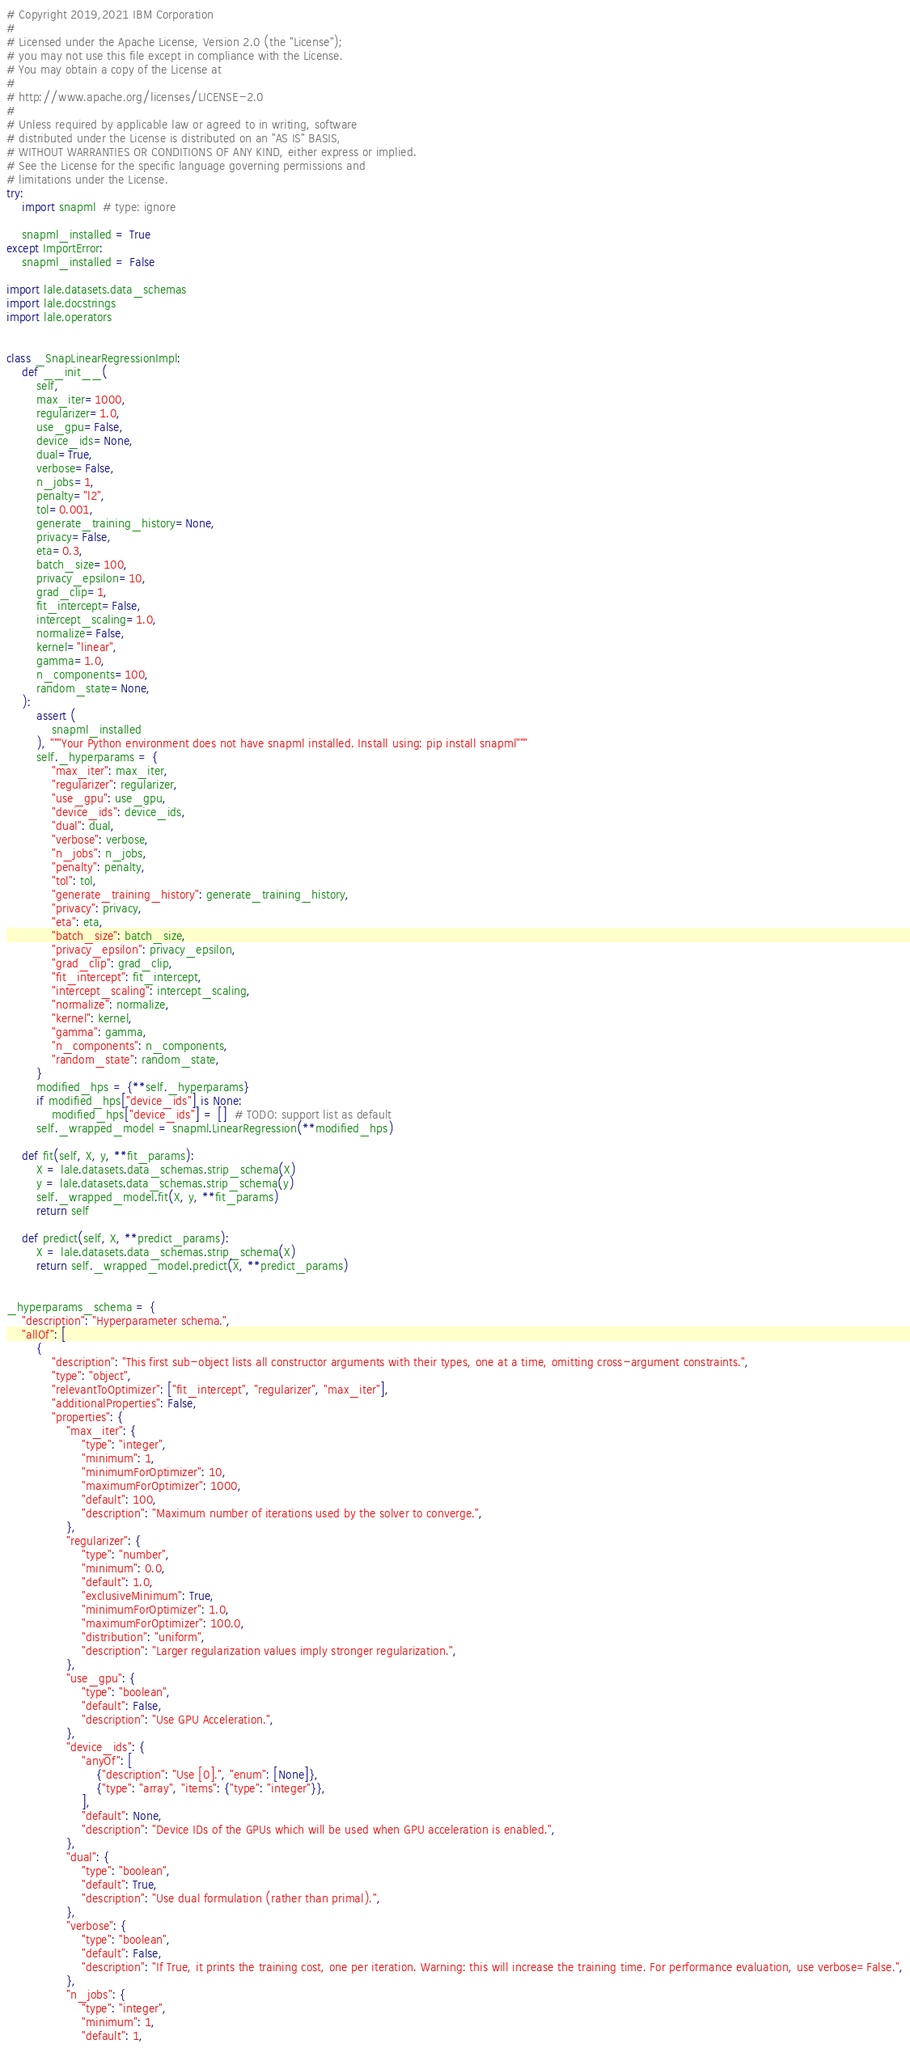<code> <loc_0><loc_0><loc_500><loc_500><_Python_># Copyright 2019,2021 IBM Corporation
#
# Licensed under the Apache License, Version 2.0 (the "License");
# you may not use this file except in compliance with the License.
# You may obtain a copy of the License at
#
# http://www.apache.org/licenses/LICENSE-2.0
#
# Unless required by applicable law or agreed to in writing, software
# distributed under the License is distributed on an "AS IS" BASIS,
# WITHOUT WARRANTIES OR CONDITIONS OF ANY KIND, either express or implied.
# See the License for the specific language governing permissions and
# limitations under the License.
try:
    import snapml  # type: ignore

    snapml_installed = True
except ImportError:
    snapml_installed = False

import lale.datasets.data_schemas
import lale.docstrings
import lale.operators


class _SnapLinearRegressionImpl:
    def __init__(
        self,
        max_iter=1000,
        regularizer=1.0,
        use_gpu=False,
        device_ids=None,
        dual=True,
        verbose=False,
        n_jobs=1,
        penalty="l2",
        tol=0.001,
        generate_training_history=None,
        privacy=False,
        eta=0.3,
        batch_size=100,
        privacy_epsilon=10,
        grad_clip=1,
        fit_intercept=False,
        intercept_scaling=1.0,
        normalize=False,
        kernel="linear",
        gamma=1.0,
        n_components=100,
        random_state=None,
    ):
        assert (
            snapml_installed
        ), """Your Python environment does not have snapml installed. Install using: pip install snapml"""
        self._hyperparams = {
            "max_iter": max_iter,
            "regularizer": regularizer,
            "use_gpu": use_gpu,
            "device_ids": device_ids,
            "dual": dual,
            "verbose": verbose,
            "n_jobs": n_jobs,
            "penalty": penalty,
            "tol": tol,
            "generate_training_history": generate_training_history,
            "privacy": privacy,
            "eta": eta,
            "batch_size": batch_size,
            "privacy_epsilon": privacy_epsilon,
            "grad_clip": grad_clip,
            "fit_intercept": fit_intercept,
            "intercept_scaling": intercept_scaling,
            "normalize": normalize,
            "kernel": kernel,
            "gamma": gamma,
            "n_components": n_components,
            "random_state": random_state,
        }
        modified_hps = {**self._hyperparams}
        if modified_hps["device_ids"] is None:
            modified_hps["device_ids"] = []  # TODO: support list as default
        self._wrapped_model = snapml.LinearRegression(**modified_hps)

    def fit(self, X, y, **fit_params):
        X = lale.datasets.data_schemas.strip_schema(X)
        y = lale.datasets.data_schemas.strip_schema(y)
        self._wrapped_model.fit(X, y, **fit_params)
        return self

    def predict(self, X, **predict_params):
        X = lale.datasets.data_schemas.strip_schema(X)
        return self._wrapped_model.predict(X, **predict_params)


_hyperparams_schema = {
    "description": "Hyperparameter schema.",
    "allOf": [
        {
            "description": "This first sub-object lists all constructor arguments with their types, one at a time, omitting cross-argument constraints.",
            "type": "object",
            "relevantToOptimizer": ["fit_intercept", "regularizer", "max_iter"],
            "additionalProperties": False,
            "properties": {
                "max_iter": {
                    "type": "integer",
                    "minimum": 1,
                    "minimumForOptimizer": 10,
                    "maximumForOptimizer": 1000,
                    "default": 100,
                    "description": "Maximum number of iterations used by the solver to converge.",
                },
                "regularizer": {
                    "type": "number",
                    "minimum": 0.0,
                    "default": 1.0,
                    "exclusiveMinimum": True,
                    "minimumForOptimizer": 1.0,
                    "maximumForOptimizer": 100.0,
                    "distribution": "uniform",
                    "description": "Larger regularization values imply stronger regularization.",
                },
                "use_gpu": {
                    "type": "boolean",
                    "default": False,
                    "description": "Use GPU Acceleration.",
                },
                "device_ids": {
                    "anyOf": [
                        {"description": "Use [0].", "enum": [None]},
                        {"type": "array", "items": {"type": "integer"}},
                    ],
                    "default": None,
                    "description": "Device IDs of the GPUs which will be used when GPU acceleration is enabled.",
                },
                "dual": {
                    "type": "boolean",
                    "default": True,
                    "description": "Use dual formulation (rather than primal).",
                },
                "verbose": {
                    "type": "boolean",
                    "default": False,
                    "description": "If True, it prints the training cost, one per iteration. Warning: this will increase the training time. For performance evaluation, use verbose=False.",
                },
                "n_jobs": {
                    "type": "integer",
                    "minimum": 1,
                    "default": 1,</code> 